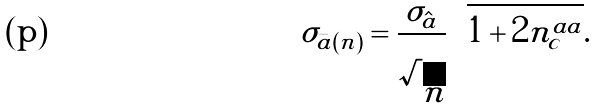<formula> <loc_0><loc_0><loc_500><loc_500>\sigma _ { \bar { a } ( n ) } & = \frac { \sigma _ { \hat { a } } } { \sqrt { n } } \sqrt { 1 + 2 n _ { c } ^ { a a } } .</formula> 